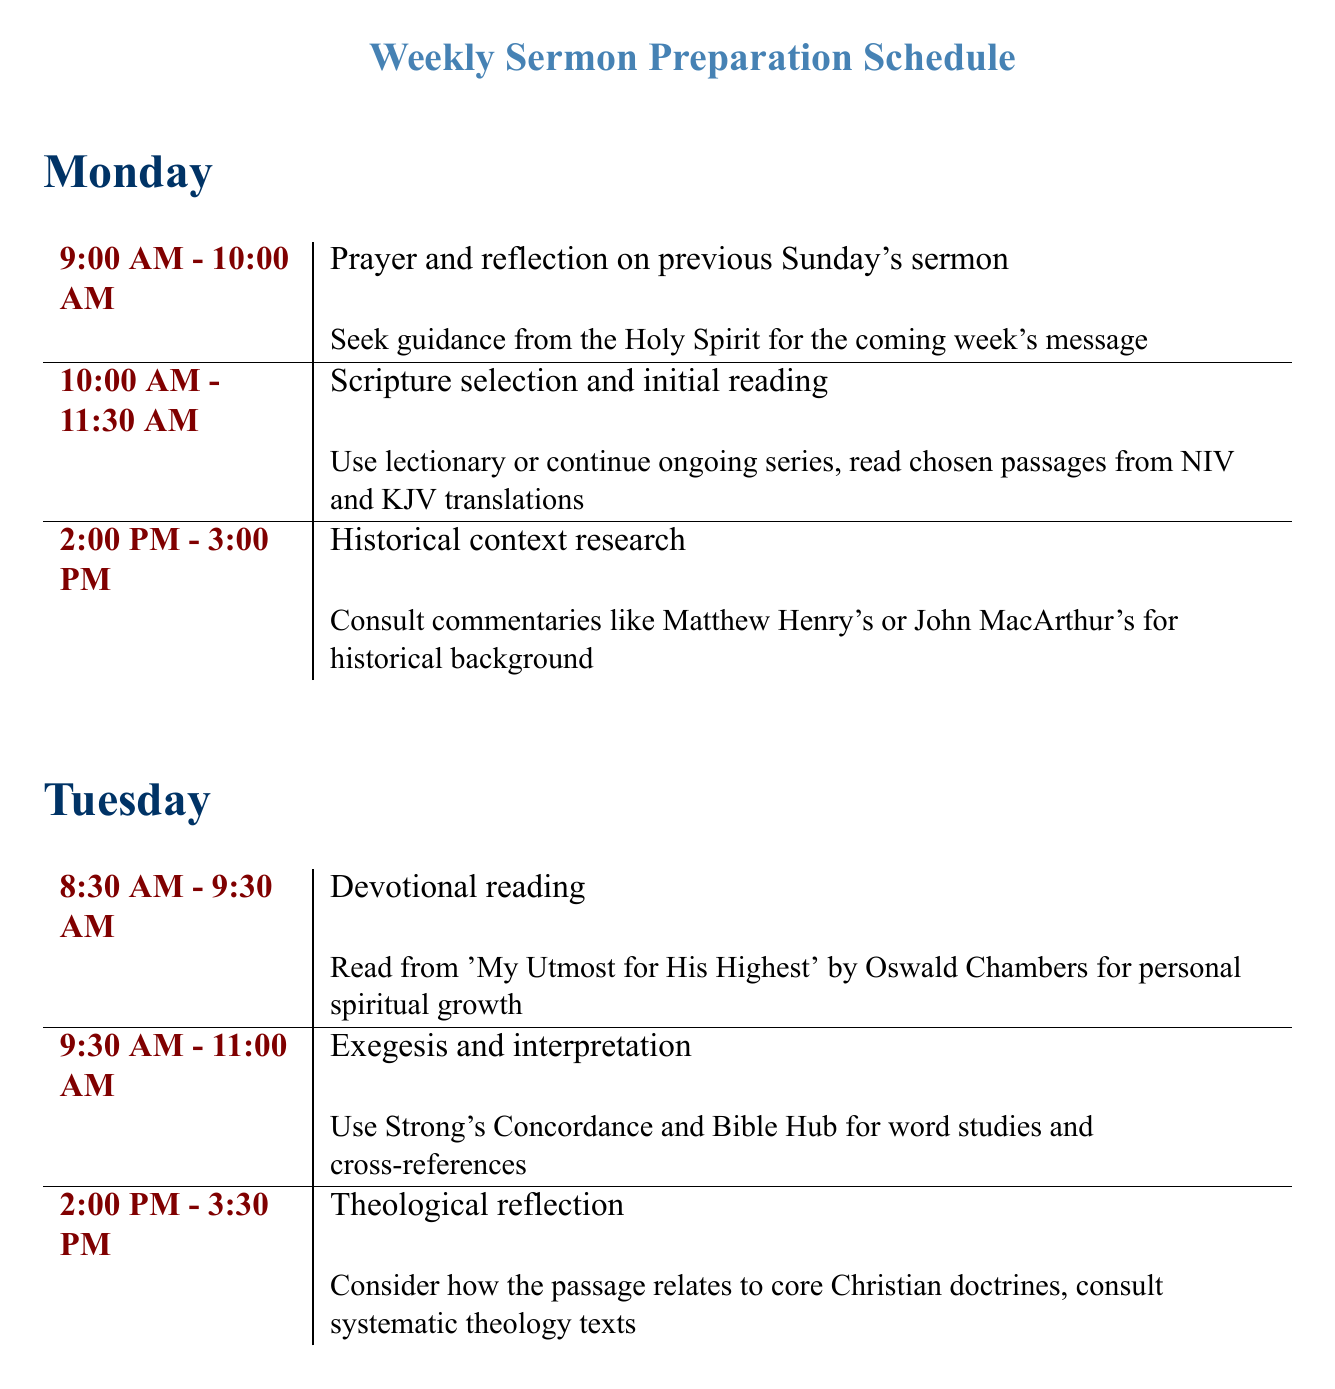What is the first activity on Monday? The first activity listed is "Prayer and reflection on previous Sunday's sermon."
Answer: Prayer and reflection on previous Sunday's sermon How many hours are dedicated to Scripture selection and initial reading on Monday? The scheduled time for this activity is from 10:00 AM to 11:30 AM, which amounts to 1.5 hours.
Answer: 1.5 hours What book is referenced for devotional reading on Tuesday? The document specifies reading "My Utmost for His Highest" by Oswald Chambers.
Answer: My Utmost for His Highest What activity is planned for 9:00 AM on Saturday? The activity listed for that time is reviewing the sermon with a spouse or trusted colleague.
Answer: Review sermon with spouse or trusted colleague On which day is the final draft of the sermon completed? The final draft is completed on Friday, as indicated in the schedule.
Answer: Friday What task do ministers perform at 2:00 PM on Wednesday? The task at that time is "Illustration and application brainstorming."
Answer: Illustration and application brainstorming How long is the early morning prayer time on Sunday? The early morning prayer and meditation occurs from 6:00 AM to 7:00 AM, lasting one hour.
Answer: 1 hour What is the focus of the final prayer and reflection on Saturday? The focus is to commit the message to God and pray for the congregation's receptivity.
Answer: Commit the message to God What is the scheduled time for delivering the sermon on Sunday? The sermon is scheduled for 11:00 AM to 12:15 PM.
Answer: 11:00 AM - 12:15 PM 